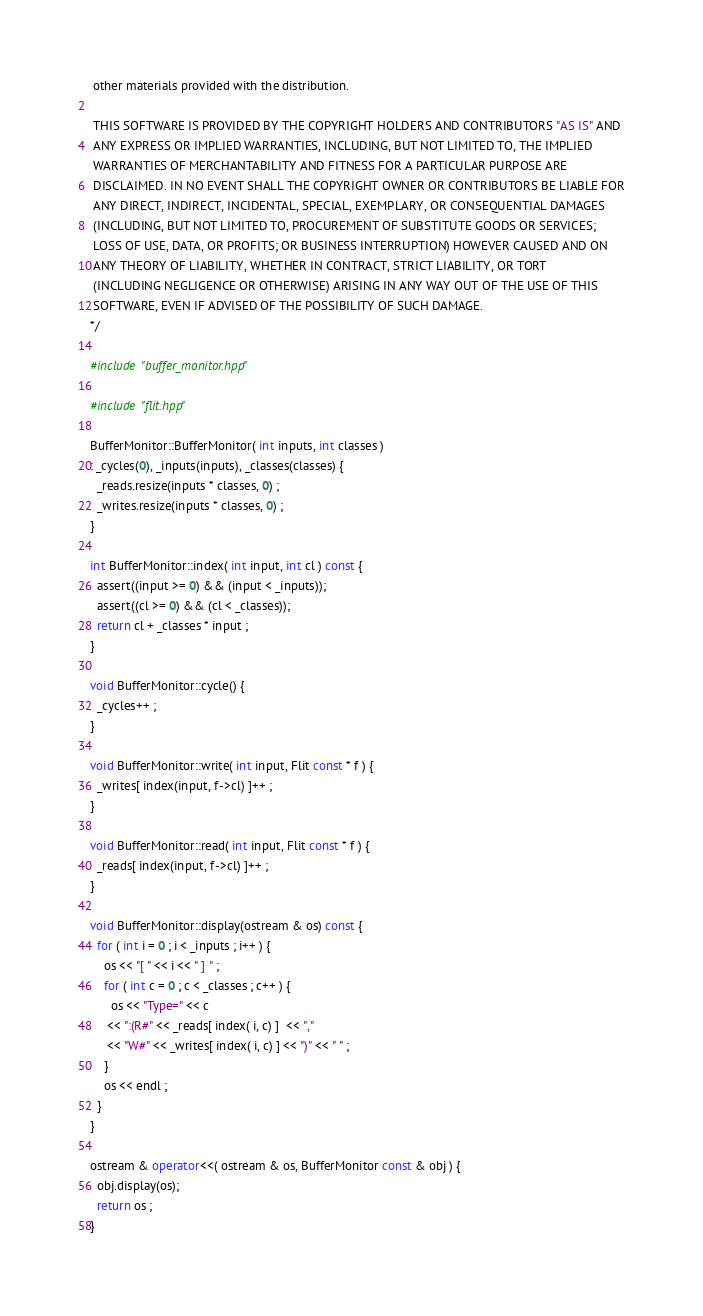Convert code to text. <code><loc_0><loc_0><loc_500><loc_500><_C++_> other materials provided with the distribution.

 THIS SOFTWARE IS PROVIDED BY THE COPYRIGHT HOLDERS AND CONTRIBUTORS "AS IS" AND
 ANY EXPRESS OR IMPLIED WARRANTIES, INCLUDING, BUT NOT LIMITED TO, THE IMPLIED
 WARRANTIES OF MERCHANTABILITY AND FITNESS FOR A PARTICULAR PURPOSE ARE 
 DISCLAIMED. IN NO EVENT SHALL THE COPYRIGHT OWNER OR CONTRIBUTORS BE LIABLE FOR
 ANY DIRECT, INDIRECT, INCIDENTAL, SPECIAL, EXEMPLARY, OR CONSEQUENTIAL DAMAGES
 (INCLUDING, BUT NOT LIMITED TO, PROCUREMENT OF SUBSTITUTE GOODS OR SERVICES;
 LOSS OF USE, DATA, OR PROFITS; OR BUSINESS INTERRUPTION) HOWEVER CAUSED AND ON
 ANY THEORY OF LIABILITY, WHETHER IN CONTRACT, STRICT LIABILITY, OR TORT
 (INCLUDING NEGLIGENCE OR OTHERWISE) ARISING IN ANY WAY OUT OF THE USE OF THIS
 SOFTWARE, EVEN IF ADVISED OF THE POSSIBILITY OF SUCH DAMAGE.
*/

#include "buffer_monitor.hpp"

#include "flit.hpp"

BufferMonitor::BufferMonitor( int inputs, int classes ) 
: _cycles(0), _inputs(inputs), _classes(classes) {
  _reads.resize(inputs * classes, 0) ;
  _writes.resize(inputs * classes, 0) ;
}

int BufferMonitor::index( int input, int cl ) const {
  assert((input >= 0) && (input < _inputs)); 
  assert((cl >= 0) && (cl < _classes));
  return cl + _classes * input ;
}

void BufferMonitor::cycle() {
  _cycles++ ;
}

void BufferMonitor::write( int input, Flit const * f ) {
  _writes[ index(input, f->cl) ]++ ;
}

void BufferMonitor::read( int input, Flit const * f ) {
  _reads[ index(input, f->cl) ]++ ;
}

void BufferMonitor::display(ostream & os) const {
  for ( int i = 0 ; i < _inputs ; i++ ) {
    os << "[ " << i << " ] " ;
    for ( int c = 0 ; c < _classes ; c++ ) {
      os << "Type=" << c
	 << ":(R#" << _reads[ index( i, c) ]  << ","
	 << "W#" << _writes[ index( i, c) ] << ")" << " " ;
    }
    os << endl ;
  }
}

ostream & operator<<( ostream & os, BufferMonitor const & obj ) {
  obj.display(os);
  return os ;
}
</code> 